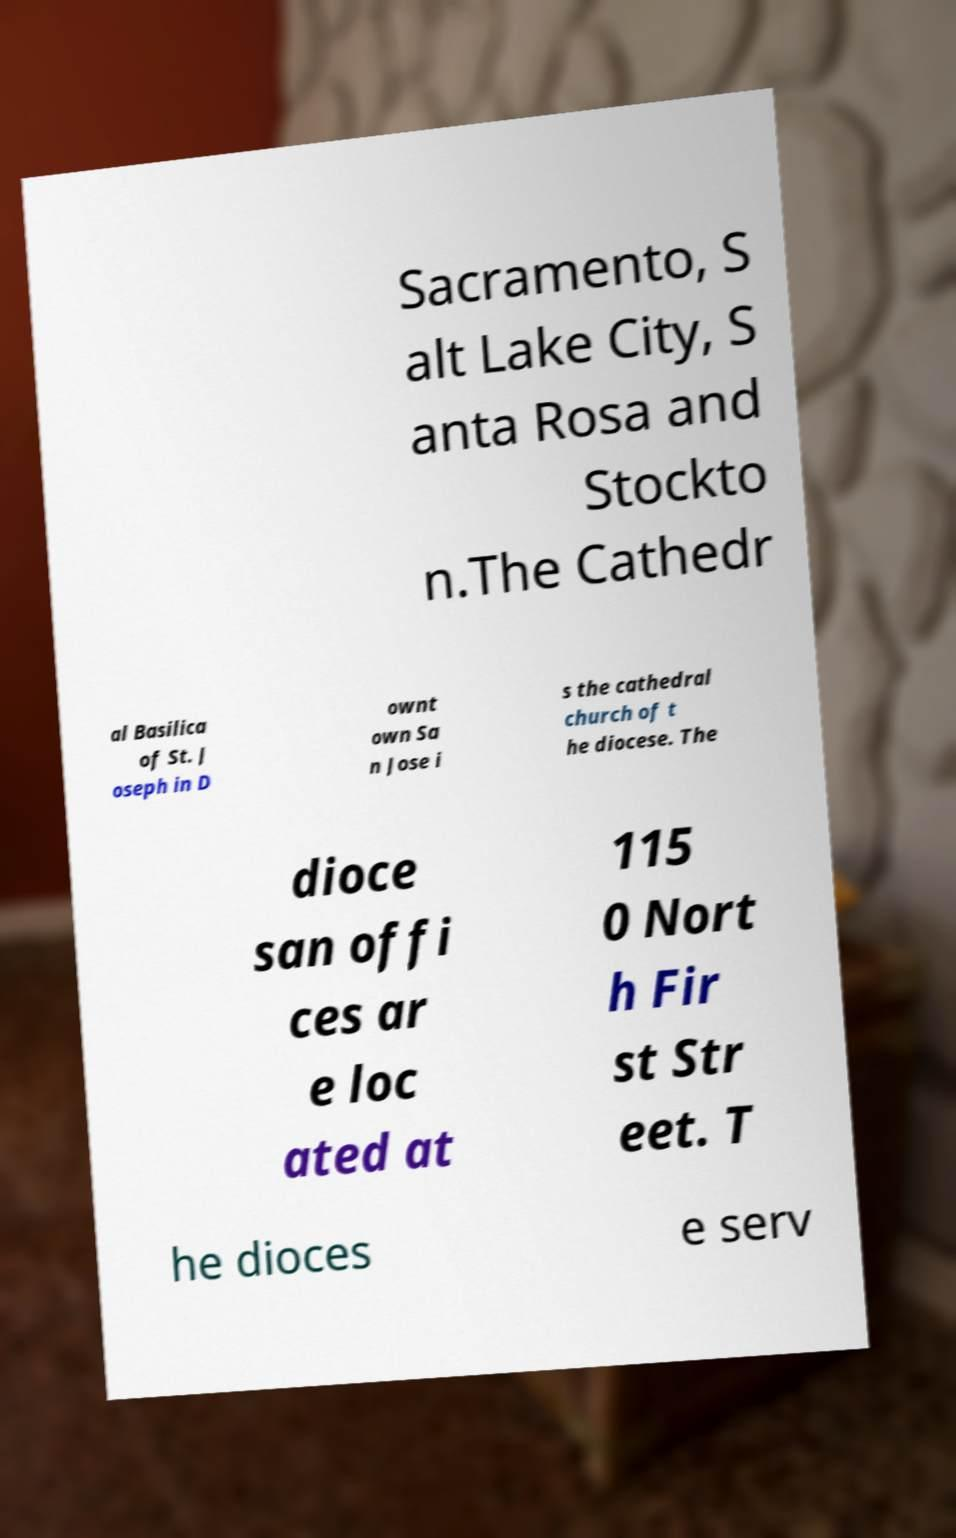For documentation purposes, I need the text within this image transcribed. Could you provide that? Sacramento, S alt Lake City, S anta Rosa and Stockto n.The Cathedr al Basilica of St. J oseph in D ownt own Sa n Jose i s the cathedral church of t he diocese. The dioce san offi ces ar e loc ated at 115 0 Nort h Fir st Str eet. T he dioces e serv 